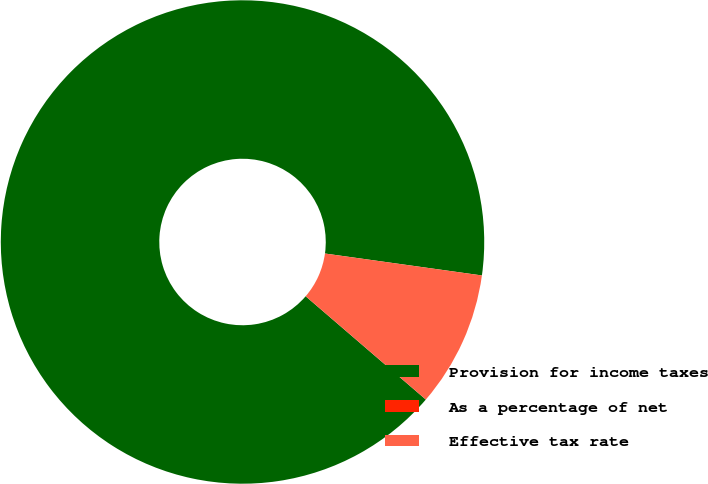Convert chart to OTSL. <chart><loc_0><loc_0><loc_500><loc_500><pie_chart><fcel>Provision for income taxes<fcel>As a percentage of net<fcel>Effective tax rate<nl><fcel>90.91%<fcel>0.0%<fcel>9.09%<nl></chart> 